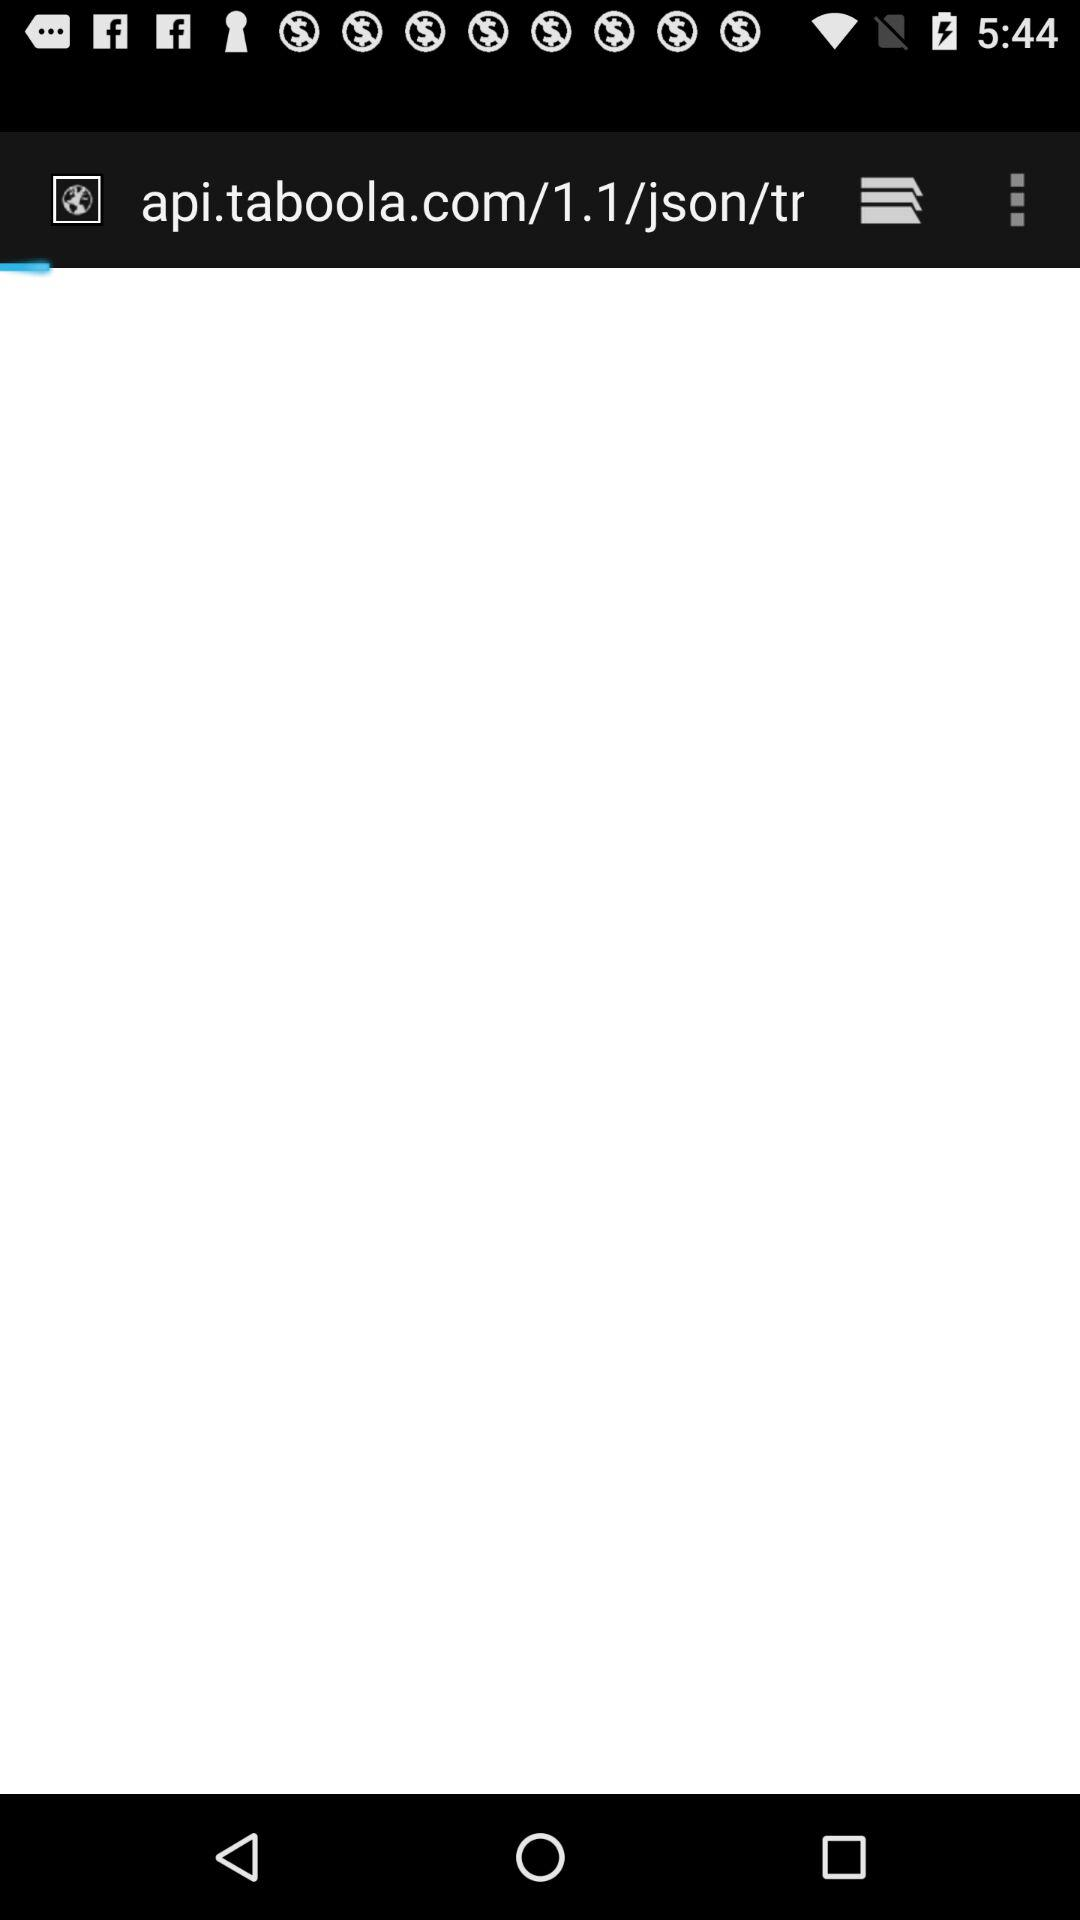Will it be warm and sunny tomorrow?
When the provided information is insufficient, respond with <no answer>. <no answer> 